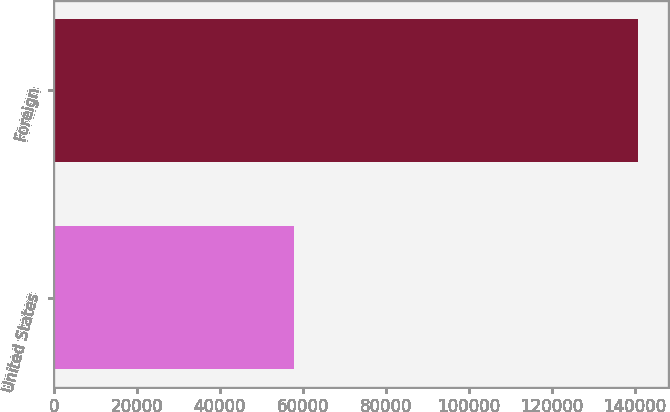Convert chart to OTSL. <chart><loc_0><loc_0><loc_500><loc_500><bar_chart><fcel>United States<fcel>Foreign<nl><fcel>57795<fcel>140863<nl></chart> 